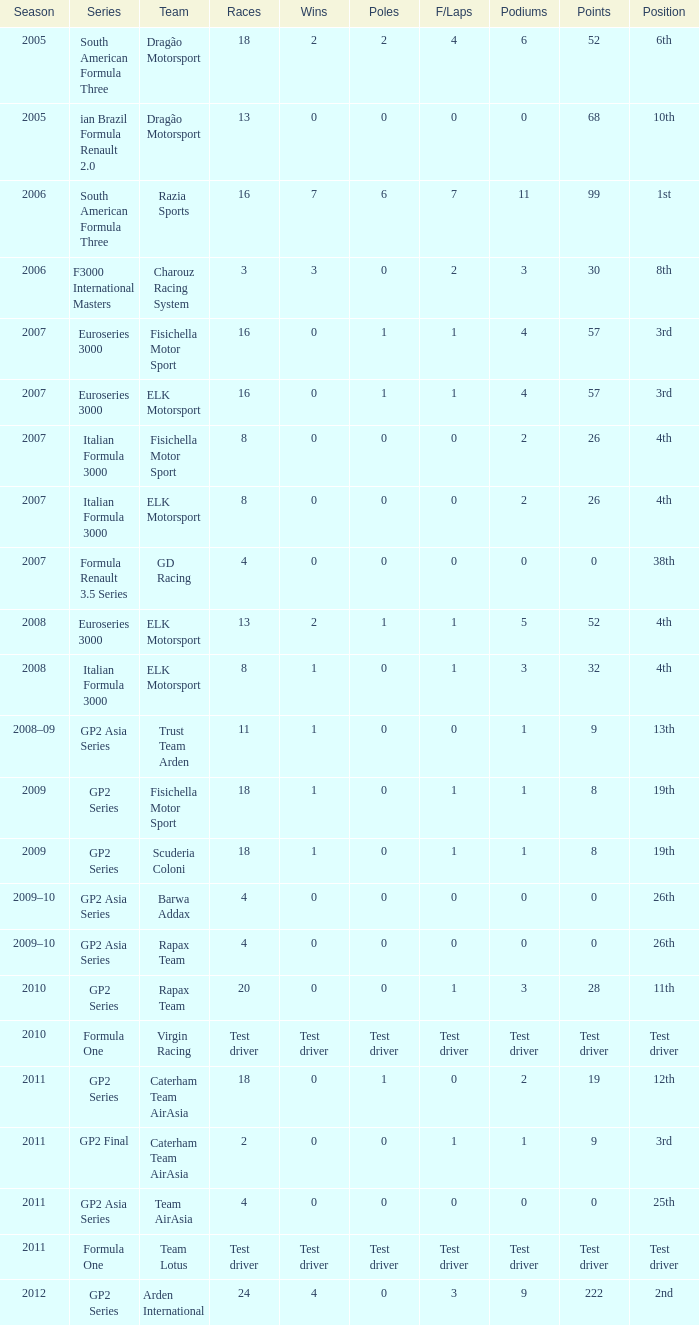During which periods of the year did he have five podium finishes? 52.0. Parse the table in full. {'header': ['Season', 'Series', 'Team', 'Races', 'Wins', 'Poles', 'F/Laps', 'Podiums', 'Points', 'Position'], 'rows': [['2005', 'South American Formula Three', 'Dragão Motorsport', '18', '2', '2', '4', '6', '52', '6th'], ['2005', 'ian Brazil Formula Renault 2.0', 'Dragão Motorsport', '13', '0', '0', '0', '0', '68', '10th'], ['2006', 'South American Formula Three', 'Razia Sports', '16', '7', '6', '7', '11', '99', '1st'], ['2006', 'F3000 International Masters', 'Charouz Racing System', '3', '3', '0', '2', '3', '30', '8th'], ['2007', 'Euroseries 3000', 'Fisichella Motor Sport', '16', '0', '1', '1', '4', '57', '3rd'], ['2007', 'Euroseries 3000', 'ELK Motorsport', '16', '0', '1', '1', '4', '57', '3rd'], ['2007', 'Italian Formula 3000', 'Fisichella Motor Sport', '8', '0', '0', '0', '2', '26', '4th'], ['2007', 'Italian Formula 3000', 'ELK Motorsport', '8', '0', '0', '0', '2', '26', '4th'], ['2007', 'Formula Renault 3.5 Series', 'GD Racing', '4', '0', '0', '0', '0', '0', '38th'], ['2008', 'Euroseries 3000', 'ELK Motorsport', '13', '2', '1', '1', '5', '52', '4th'], ['2008', 'Italian Formula 3000', 'ELK Motorsport', '8', '1', '0', '1', '3', '32', '4th'], ['2008–09', 'GP2 Asia Series', 'Trust Team Arden', '11', '1', '0', '0', '1', '9', '13th'], ['2009', 'GP2 Series', 'Fisichella Motor Sport', '18', '1', '0', '1', '1', '8', '19th'], ['2009', 'GP2 Series', 'Scuderia Coloni', '18', '1', '0', '1', '1', '8', '19th'], ['2009–10', 'GP2 Asia Series', 'Barwa Addax', '4', '0', '0', '0', '0', '0', '26th'], ['2009–10', 'GP2 Asia Series', 'Rapax Team', '4', '0', '0', '0', '0', '0', '26th'], ['2010', 'GP2 Series', 'Rapax Team', '20', '0', '0', '1', '3', '28', '11th'], ['2010', 'Formula One', 'Virgin Racing', 'Test driver', 'Test driver', 'Test driver', 'Test driver', 'Test driver', 'Test driver', 'Test driver'], ['2011', 'GP2 Series', 'Caterham Team AirAsia', '18', '0', '1', '0', '2', '19', '12th'], ['2011', 'GP2 Final', 'Caterham Team AirAsia', '2', '0', '0', '1', '1', '9', '3rd'], ['2011', 'GP2 Asia Series', 'Team AirAsia', '4', '0', '0', '0', '0', '0', '25th'], ['2011', 'Formula One', 'Team Lotus', 'Test driver', 'Test driver', 'Test driver', 'Test driver', 'Test driver', 'Test driver', 'Test driver'], ['2012', 'GP2 Series', 'Arden International', '24', '4', '0', '3', '9', '222', '2nd']]} 